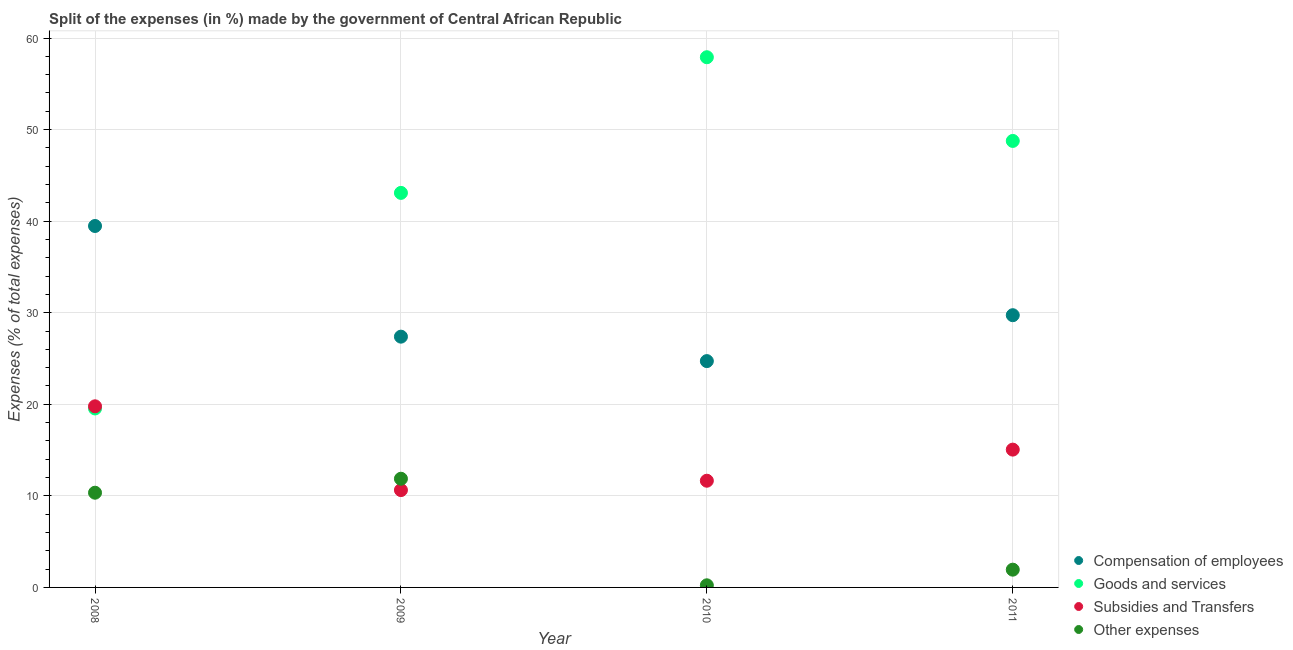How many different coloured dotlines are there?
Provide a short and direct response. 4. Is the number of dotlines equal to the number of legend labels?
Your response must be concise. Yes. What is the percentage of amount spent on compensation of employees in 2011?
Provide a short and direct response. 29.73. Across all years, what is the maximum percentage of amount spent on other expenses?
Your answer should be compact. 11.87. Across all years, what is the minimum percentage of amount spent on other expenses?
Offer a very short reply. 0.23. In which year was the percentage of amount spent on compensation of employees minimum?
Provide a short and direct response. 2010. What is the total percentage of amount spent on other expenses in the graph?
Your response must be concise. 24.38. What is the difference between the percentage of amount spent on compensation of employees in 2009 and that in 2011?
Ensure brevity in your answer.  -2.34. What is the difference between the percentage of amount spent on other expenses in 2010 and the percentage of amount spent on compensation of employees in 2008?
Give a very brief answer. -39.24. What is the average percentage of amount spent on goods and services per year?
Provide a short and direct response. 42.33. In the year 2011, what is the difference between the percentage of amount spent on goods and services and percentage of amount spent on compensation of employees?
Offer a very short reply. 19.03. In how many years, is the percentage of amount spent on goods and services greater than 54 %?
Offer a very short reply. 1. What is the ratio of the percentage of amount spent on other expenses in 2010 to that in 2011?
Provide a succinct answer. 0.12. Is the percentage of amount spent on other expenses in 2009 less than that in 2011?
Your answer should be very brief. No. Is the difference between the percentage of amount spent on subsidies in 2009 and 2010 greater than the difference between the percentage of amount spent on compensation of employees in 2009 and 2010?
Ensure brevity in your answer.  No. What is the difference between the highest and the second highest percentage of amount spent on compensation of employees?
Make the answer very short. 9.74. What is the difference between the highest and the lowest percentage of amount spent on goods and services?
Your answer should be very brief. 38.36. In how many years, is the percentage of amount spent on other expenses greater than the average percentage of amount spent on other expenses taken over all years?
Ensure brevity in your answer.  2. Is it the case that in every year, the sum of the percentage of amount spent on compensation of employees and percentage of amount spent on goods and services is greater than the sum of percentage of amount spent on subsidies and percentage of amount spent on other expenses?
Make the answer very short. Yes. Does the percentage of amount spent on other expenses monotonically increase over the years?
Offer a terse response. No. Is the percentage of amount spent on subsidies strictly less than the percentage of amount spent on other expenses over the years?
Your answer should be very brief. No. What is the difference between two consecutive major ticks on the Y-axis?
Offer a terse response. 10. Are the values on the major ticks of Y-axis written in scientific E-notation?
Offer a terse response. No. Does the graph contain any zero values?
Provide a short and direct response. No. Where does the legend appear in the graph?
Give a very brief answer. Bottom right. How many legend labels are there?
Your answer should be very brief. 4. How are the legend labels stacked?
Provide a short and direct response. Vertical. What is the title of the graph?
Provide a short and direct response. Split of the expenses (in %) made by the government of Central African Republic. Does "Denmark" appear as one of the legend labels in the graph?
Keep it short and to the point. No. What is the label or title of the X-axis?
Offer a very short reply. Year. What is the label or title of the Y-axis?
Provide a short and direct response. Expenses (% of total expenses). What is the Expenses (% of total expenses) of Compensation of employees in 2008?
Keep it short and to the point. 39.47. What is the Expenses (% of total expenses) of Goods and services in 2008?
Ensure brevity in your answer.  19.55. What is the Expenses (% of total expenses) in Subsidies and Transfers in 2008?
Your answer should be compact. 19.78. What is the Expenses (% of total expenses) of Other expenses in 2008?
Keep it short and to the point. 10.34. What is the Expenses (% of total expenses) of Compensation of employees in 2009?
Keep it short and to the point. 27.39. What is the Expenses (% of total expenses) of Goods and services in 2009?
Your response must be concise. 43.09. What is the Expenses (% of total expenses) in Subsidies and Transfers in 2009?
Give a very brief answer. 10.63. What is the Expenses (% of total expenses) in Other expenses in 2009?
Provide a succinct answer. 11.87. What is the Expenses (% of total expenses) of Compensation of employees in 2010?
Your answer should be compact. 24.72. What is the Expenses (% of total expenses) in Goods and services in 2010?
Ensure brevity in your answer.  57.91. What is the Expenses (% of total expenses) of Subsidies and Transfers in 2010?
Your answer should be compact. 11.65. What is the Expenses (% of total expenses) of Other expenses in 2010?
Offer a terse response. 0.23. What is the Expenses (% of total expenses) in Compensation of employees in 2011?
Provide a succinct answer. 29.73. What is the Expenses (% of total expenses) in Goods and services in 2011?
Your response must be concise. 48.76. What is the Expenses (% of total expenses) of Subsidies and Transfers in 2011?
Offer a very short reply. 15.05. What is the Expenses (% of total expenses) of Other expenses in 2011?
Give a very brief answer. 1.94. Across all years, what is the maximum Expenses (% of total expenses) of Compensation of employees?
Your answer should be compact. 39.47. Across all years, what is the maximum Expenses (% of total expenses) in Goods and services?
Ensure brevity in your answer.  57.91. Across all years, what is the maximum Expenses (% of total expenses) of Subsidies and Transfers?
Offer a very short reply. 19.78. Across all years, what is the maximum Expenses (% of total expenses) in Other expenses?
Provide a succinct answer. 11.87. Across all years, what is the minimum Expenses (% of total expenses) of Compensation of employees?
Your answer should be compact. 24.72. Across all years, what is the minimum Expenses (% of total expenses) in Goods and services?
Offer a terse response. 19.55. Across all years, what is the minimum Expenses (% of total expenses) of Subsidies and Transfers?
Ensure brevity in your answer.  10.63. Across all years, what is the minimum Expenses (% of total expenses) of Other expenses?
Provide a short and direct response. 0.23. What is the total Expenses (% of total expenses) in Compensation of employees in the graph?
Keep it short and to the point. 121.31. What is the total Expenses (% of total expenses) in Goods and services in the graph?
Your answer should be very brief. 169.3. What is the total Expenses (% of total expenses) in Subsidies and Transfers in the graph?
Your response must be concise. 57.11. What is the total Expenses (% of total expenses) in Other expenses in the graph?
Make the answer very short. 24.38. What is the difference between the Expenses (% of total expenses) in Compensation of employees in 2008 and that in 2009?
Provide a succinct answer. 12.09. What is the difference between the Expenses (% of total expenses) of Goods and services in 2008 and that in 2009?
Offer a terse response. -23.54. What is the difference between the Expenses (% of total expenses) of Subsidies and Transfers in 2008 and that in 2009?
Your response must be concise. 9.15. What is the difference between the Expenses (% of total expenses) of Other expenses in 2008 and that in 2009?
Keep it short and to the point. -1.53. What is the difference between the Expenses (% of total expenses) in Compensation of employees in 2008 and that in 2010?
Your response must be concise. 14.76. What is the difference between the Expenses (% of total expenses) of Goods and services in 2008 and that in 2010?
Offer a very short reply. -38.36. What is the difference between the Expenses (% of total expenses) in Subsidies and Transfers in 2008 and that in 2010?
Offer a terse response. 8.13. What is the difference between the Expenses (% of total expenses) in Other expenses in 2008 and that in 2010?
Your response must be concise. 10.11. What is the difference between the Expenses (% of total expenses) in Compensation of employees in 2008 and that in 2011?
Your answer should be compact. 9.74. What is the difference between the Expenses (% of total expenses) of Goods and services in 2008 and that in 2011?
Offer a very short reply. -29.22. What is the difference between the Expenses (% of total expenses) of Subsidies and Transfers in 2008 and that in 2011?
Give a very brief answer. 4.73. What is the difference between the Expenses (% of total expenses) in Other expenses in 2008 and that in 2011?
Make the answer very short. 8.4. What is the difference between the Expenses (% of total expenses) in Compensation of employees in 2009 and that in 2010?
Keep it short and to the point. 2.67. What is the difference between the Expenses (% of total expenses) of Goods and services in 2009 and that in 2010?
Your answer should be compact. -14.82. What is the difference between the Expenses (% of total expenses) of Subsidies and Transfers in 2009 and that in 2010?
Provide a short and direct response. -1.02. What is the difference between the Expenses (% of total expenses) in Other expenses in 2009 and that in 2010?
Ensure brevity in your answer.  11.64. What is the difference between the Expenses (% of total expenses) in Compensation of employees in 2009 and that in 2011?
Your answer should be compact. -2.34. What is the difference between the Expenses (% of total expenses) in Goods and services in 2009 and that in 2011?
Make the answer very short. -5.68. What is the difference between the Expenses (% of total expenses) in Subsidies and Transfers in 2009 and that in 2011?
Your answer should be very brief. -4.42. What is the difference between the Expenses (% of total expenses) of Other expenses in 2009 and that in 2011?
Provide a succinct answer. 9.93. What is the difference between the Expenses (% of total expenses) of Compensation of employees in 2010 and that in 2011?
Offer a very short reply. -5.01. What is the difference between the Expenses (% of total expenses) in Goods and services in 2010 and that in 2011?
Make the answer very short. 9.14. What is the difference between the Expenses (% of total expenses) of Subsidies and Transfers in 2010 and that in 2011?
Provide a short and direct response. -3.4. What is the difference between the Expenses (% of total expenses) in Other expenses in 2010 and that in 2011?
Your answer should be very brief. -1.71. What is the difference between the Expenses (% of total expenses) of Compensation of employees in 2008 and the Expenses (% of total expenses) of Goods and services in 2009?
Keep it short and to the point. -3.61. What is the difference between the Expenses (% of total expenses) of Compensation of employees in 2008 and the Expenses (% of total expenses) of Subsidies and Transfers in 2009?
Your response must be concise. 28.84. What is the difference between the Expenses (% of total expenses) of Compensation of employees in 2008 and the Expenses (% of total expenses) of Other expenses in 2009?
Keep it short and to the point. 27.6. What is the difference between the Expenses (% of total expenses) in Goods and services in 2008 and the Expenses (% of total expenses) in Subsidies and Transfers in 2009?
Your response must be concise. 8.91. What is the difference between the Expenses (% of total expenses) in Goods and services in 2008 and the Expenses (% of total expenses) in Other expenses in 2009?
Keep it short and to the point. 7.68. What is the difference between the Expenses (% of total expenses) in Subsidies and Transfers in 2008 and the Expenses (% of total expenses) in Other expenses in 2009?
Make the answer very short. 7.91. What is the difference between the Expenses (% of total expenses) of Compensation of employees in 2008 and the Expenses (% of total expenses) of Goods and services in 2010?
Your answer should be compact. -18.43. What is the difference between the Expenses (% of total expenses) of Compensation of employees in 2008 and the Expenses (% of total expenses) of Subsidies and Transfers in 2010?
Offer a terse response. 27.82. What is the difference between the Expenses (% of total expenses) in Compensation of employees in 2008 and the Expenses (% of total expenses) in Other expenses in 2010?
Make the answer very short. 39.24. What is the difference between the Expenses (% of total expenses) of Goods and services in 2008 and the Expenses (% of total expenses) of Subsidies and Transfers in 2010?
Offer a very short reply. 7.89. What is the difference between the Expenses (% of total expenses) in Goods and services in 2008 and the Expenses (% of total expenses) in Other expenses in 2010?
Your answer should be compact. 19.31. What is the difference between the Expenses (% of total expenses) of Subsidies and Transfers in 2008 and the Expenses (% of total expenses) of Other expenses in 2010?
Provide a short and direct response. 19.55. What is the difference between the Expenses (% of total expenses) of Compensation of employees in 2008 and the Expenses (% of total expenses) of Goods and services in 2011?
Offer a very short reply. -9.29. What is the difference between the Expenses (% of total expenses) of Compensation of employees in 2008 and the Expenses (% of total expenses) of Subsidies and Transfers in 2011?
Offer a very short reply. 24.42. What is the difference between the Expenses (% of total expenses) in Compensation of employees in 2008 and the Expenses (% of total expenses) in Other expenses in 2011?
Give a very brief answer. 37.53. What is the difference between the Expenses (% of total expenses) of Goods and services in 2008 and the Expenses (% of total expenses) of Subsidies and Transfers in 2011?
Offer a very short reply. 4.5. What is the difference between the Expenses (% of total expenses) in Goods and services in 2008 and the Expenses (% of total expenses) in Other expenses in 2011?
Provide a succinct answer. 17.61. What is the difference between the Expenses (% of total expenses) of Subsidies and Transfers in 2008 and the Expenses (% of total expenses) of Other expenses in 2011?
Your answer should be compact. 17.84. What is the difference between the Expenses (% of total expenses) of Compensation of employees in 2009 and the Expenses (% of total expenses) of Goods and services in 2010?
Give a very brief answer. -30.52. What is the difference between the Expenses (% of total expenses) in Compensation of employees in 2009 and the Expenses (% of total expenses) in Subsidies and Transfers in 2010?
Your answer should be very brief. 15.73. What is the difference between the Expenses (% of total expenses) in Compensation of employees in 2009 and the Expenses (% of total expenses) in Other expenses in 2010?
Give a very brief answer. 27.16. What is the difference between the Expenses (% of total expenses) in Goods and services in 2009 and the Expenses (% of total expenses) in Subsidies and Transfers in 2010?
Provide a short and direct response. 31.44. What is the difference between the Expenses (% of total expenses) of Goods and services in 2009 and the Expenses (% of total expenses) of Other expenses in 2010?
Make the answer very short. 42.86. What is the difference between the Expenses (% of total expenses) in Subsidies and Transfers in 2009 and the Expenses (% of total expenses) in Other expenses in 2010?
Provide a succinct answer. 10.4. What is the difference between the Expenses (% of total expenses) of Compensation of employees in 2009 and the Expenses (% of total expenses) of Goods and services in 2011?
Make the answer very short. -21.38. What is the difference between the Expenses (% of total expenses) in Compensation of employees in 2009 and the Expenses (% of total expenses) in Subsidies and Transfers in 2011?
Offer a terse response. 12.34. What is the difference between the Expenses (% of total expenses) of Compensation of employees in 2009 and the Expenses (% of total expenses) of Other expenses in 2011?
Ensure brevity in your answer.  25.45. What is the difference between the Expenses (% of total expenses) of Goods and services in 2009 and the Expenses (% of total expenses) of Subsidies and Transfers in 2011?
Provide a short and direct response. 28.04. What is the difference between the Expenses (% of total expenses) in Goods and services in 2009 and the Expenses (% of total expenses) in Other expenses in 2011?
Your answer should be compact. 41.15. What is the difference between the Expenses (% of total expenses) in Subsidies and Transfers in 2009 and the Expenses (% of total expenses) in Other expenses in 2011?
Your answer should be compact. 8.69. What is the difference between the Expenses (% of total expenses) in Compensation of employees in 2010 and the Expenses (% of total expenses) in Goods and services in 2011?
Your answer should be very brief. -24.05. What is the difference between the Expenses (% of total expenses) in Compensation of employees in 2010 and the Expenses (% of total expenses) in Subsidies and Transfers in 2011?
Keep it short and to the point. 9.67. What is the difference between the Expenses (% of total expenses) of Compensation of employees in 2010 and the Expenses (% of total expenses) of Other expenses in 2011?
Make the answer very short. 22.78. What is the difference between the Expenses (% of total expenses) of Goods and services in 2010 and the Expenses (% of total expenses) of Subsidies and Transfers in 2011?
Give a very brief answer. 42.85. What is the difference between the Expenses (% of total expenses) in Goods and services in 2010 and the Expenses (% of total expenses) in Other expenses in 2011?
Give a very brief answer. 55.97. What is the difference between the Expenses (% of total expenses) in Subsidies and Transfers in 2010 and the Expenses (% of total expenses) in Other expenses in 2011?
Provide a short and direct response. 9.71. What is the average Expenses (% of total expenses) of Compensation of employees per year?
Ensure brevity in your answer.  30.33. What is the average Expenses (% of total expenses) of Goods and services per year?
Provide a succinct answer. 42.33. What is the average Expenses (% of total expenses) in Subsidies and Transfers per year?
Offer a very short reply. 14.28. What is the average Expenses (% of total expenses) in Other expenses per year?
Your answer should be very brief. 6.1. In the year 2008, what is the difference between the Expenses (% of total expenses) of Compensation of employees and Expenses (% of total expenses) of Goods and services?
Your answer should be very brief. 19.93. In the year 2008, what is the difference between the Expenses (% of total expenses) in Compensation of employees and Expenses (% of total expenses) in Subsidies and Transfers?
Give a very brief answer. 19.69. In the year 2008, what is the difference between the Expenses (% of total expenses) in Compensation of employees and Expenses (% of total expenses) in Other expenses?
Ensure brevity in your answer.  29.13. In the year 2008, what is the difference between the Expenses (% of total expenses) in Goods and services and Expenses (% of total expenses) in Subsidies and Transfers?
Ensure brevity in your answer.  -0.23. In the year 2008, what is the difference between the Expenses (% of total expenses) in Goods and services and Expenses (% of total expenses) in Other expenses?
Your response must be concise. 9.2. In the year 2008, what is the difference between the Expenses (% of total expenses) of Subsidies and Transfers and Expenses (% of total expenses) of Other expenses?
Your response must be concise. 9.44. In the year 2009, what is the difference between the Expenses (% of total expenses) of Compensation of employees and Expenses (% of total expenses) of Goods and services?
Your answer should be very brief. -15.7. In the year 2009, what is the difference between the Expenses (% of total expenses) in Compensation of employees and Expenses (% of total expenses) in Subsidies and Transfers?
Offer a terse response. 16.76. In the year 2009, what is the difference between the Expenses (% of total expenses) of Compensation of employees and Expenses (% of total expenses) of Other expenses?
Your answer should be very brief. 15.52. In the year 2009, what is the difference between the Expenses (% of total expenses) in Goods and services and Expenses (% of total expenses) in Subsidies and Transfers?
Your answer should be very brief. 32.46. In the year 2009, what is the difference between the Expenses (% of total expenses) in Goods and services and Expenses (% of total expenses) in Other expenses?
Give a very brief answer. 31.22. In the year 2009, what is the difference between the Expenses (% of total expenses) in Subsidies and Transfers and Expenses (% of total expenses) in Other expenses?
Offer a very short reply. -1.24. In the year 2010, what is the difference between the Expenses (% of total expenses) of Compensation of employees and Expenses (% of total expenses) of Goods and services?
Offer a terse response. -33.19. In the year 2010, what is the difference between the Expenses (% of total expenses) of Compensation of employees and Expenses (% of total expenses) of Subsidies and Transfers?
Your response must be concise. 13.07. In the year 2010, what is the difference between the Expenses (% of total expenses) in Compensation of employees and Expenses (% of total expenses) in Other expenses?
Ensure brevity in your answer.  24.49. In the year 2010, what is the difference between the Expenses (% of total expenses) of Goods and services and Expenses (% of total expenses) of Subsidies and Transfers?
Your answer should be compact. 46.25. In the year 2010, what is the difference between the Expenses (% of total expenses) in Goods and services and Expenses (% of total expenses) in Other expenses?
Your response must be concise. 57.67. In the year 2010, what is the difference between the Expenses (% of total expenses) of Subsidies and Transfers and Expenses (% of total expenses) of Other expenses?
Make the answer very short. 11.42. In the year 2011, what is the difference between the Expenses (% of total expenses) in Compensation of employees and Expenses (% of total expenses) in Goods and services?
Ensure brevity in your answer.  -19.03. In the year 2011, what is the difference between the Expenses (% of total expenses) of Compensation of employees and Expenses (% of total expenses) of Subsidies and Transfers?
Make the answer very short. 14.68. In the year 2011, what is the difference between the Expenses (% of total expenses) of Compensation of employees and Expenses (% of total expenses) of Other expenses?
Provide a succinct answer. 27.79. In the year 2011, what is the difference between the Expenses (% of total expenses) in Goods and services and Expenses (% of total expenses) in Subsidies and Transfers?
Keep it short and to the point. 33.71. In the year 2011, what is the difference between the Expenses (% of total expenses) of Goods and services and Expenses (% of total expenses) of Other expenses?
Keep it short and to the point. 46.83. In the year 2011, what is the difference between the Expenses (% of total expenses) of Subsidies and Transfers and Expenses (% of total expenses) of Other expenses?
Give a very brief answer. 13.11. What is the ratio of the Expenses (% of total expenses) of Compensation of employees in 2008 to that in 2009?
Provide a short and direct response. 1.44. What is the ratio of the Expenses (% of total expenses) in Goods and services in 2008 to that in 2009?
Give a very brief answer. 0.45. What is the ratio of the Expenses (% of total expenses) in Subsidies and Transfers in 2008 to that in 2009?
Give a very brief answer. 1.86. What is the ratio of the Expenses (% of total expenses) in Other expenses in 2008 to that in 2009?
Offer a very short reply. 0.87. What is the ratio of the Expenses (% of total expenses) in Compensation of employees in 2008 to that in 2010?
Ensure brevity in your answer.  1.6. What is the ratio of the Expenses (% of total expenses) of Goods and services in 2008 to that in 2010?
Your response must be concise. 0.34. What is the ratio of the Expenses (% of total expenses) of Subsidies and Transfers in 2008 to that in 2010?
Your response must be concise. 1.7. What is the ratio of the Expenses (% of total expenses) in Other expenses in 2008 to that in 2010?
Your response must be concise. 44.79. What is the ratio of the Expenses (% of total expenses) in Compensation of employees in 2008 to that in 2011?
Offer a terse response. 1.33. What is the ratio of the Expenses (% of total expenses) in Goods and services in 2008 to that in 2011?
Make the answer very short. 0.4. What is the ratio of the Expenses (% of total expenses) of Subsidies and Transfers in 2008 to that in 2011?
Offer a very short reply. 1.31. What is the ratio of the Expenses (% of total expenses) in Other expenses in 2008 to that in 2011?
Give a very brief answer. 5.33. What is the ratio of the Expenses (% of total expenses) of Compensation of employees in 2009 to that in 2010?
Ensure brevity in your answer.  1.11. What is the ratio of the Expenses (% of total expenses) of Goods and services in 2009 to that in 2010?
Your answer should be very brief. 0.74. What is the ratio of the Expenses (% of total expenses) of Subsidies and Transfers in 2009 to that in 2010?
Ensure brevity in your answer.  0.91. What is the ratio of the Expenses (% of total expenses) in Other expenses in 2009 to that in 2010?
Ensure brevity in your answer.  51.4. What is the ratio of the Expenses (% of total expenses) in Compensation of employees in 2009 to that in 2011?
Your answer should be very brief. 0.92. What is the ratio of the Expenses (% of total expenses) of Goods and services in 2009 to that in 2011?
Make the answer very short. 0.88. What is the ratio of the Expenses (% of total expenses) of Subsidies and Transfers in 2009 to that in 2011?
Keep it short and to the point. 0.71. What is the ratio of the Expenses (% of total expenses) of Other expenses in 2009 to that in 2011?
Offer a terse response. 6.12. What is the ratio of the Expenses (% of total expenses) of Compensation of employees in 2010 to that in 2011?
Offer a very short reply. 0.83. What is the ratio of the Expenses (% of total expenses) in Goods and services in 2010 to that in 2011?
Your answer should be very brief. 1.19. What is the ratio of the Expenses (% of total expenses) in Subsidies and Transfers in 2010 to that in 2011?
Offer a very short reply. 0.77. What is the ratio of the Expenses (% of total expenses) in Other expenses in 2010 to that in 2011?
Offer a very short reply. 0.12. What is the difference between the highest and the second highest Expenses (% of total expenses) of Compensation of employees?
Your response must be concise. 9.74. What is the difference between the highest and the second highest Expenses (% of total expenses) of Goods and services?
Your response must be concise. 9.14. What is the difference between the highest and the second highest Expenses (% of total expenses) in Subsidies and Transfers?
Offer a terse response. 4.73. What is the difference between the highest and the second highest Expenses (% of total expenses) in Other expenses?
Provide a succinct answer. 1.53. What is the difference between the highest and the lowest Expenses (% of total expenses) of Compensation of employees?
Your answer should be very brief. 14.76. What is the difference between the highest and the lowest Expenses (% of total expenses) of Goods and services?
Ensure brevity in your answer.  38.36. What is the difference between the highest and the lowest Expenses (% of total expenses) in Subsidies and Transfers?
Offer a terse response. 9.15. What is the difference between the highest and the lowest Expenses (% of total expenses) of Other expenses?
Your response must be concise. 11.64. 